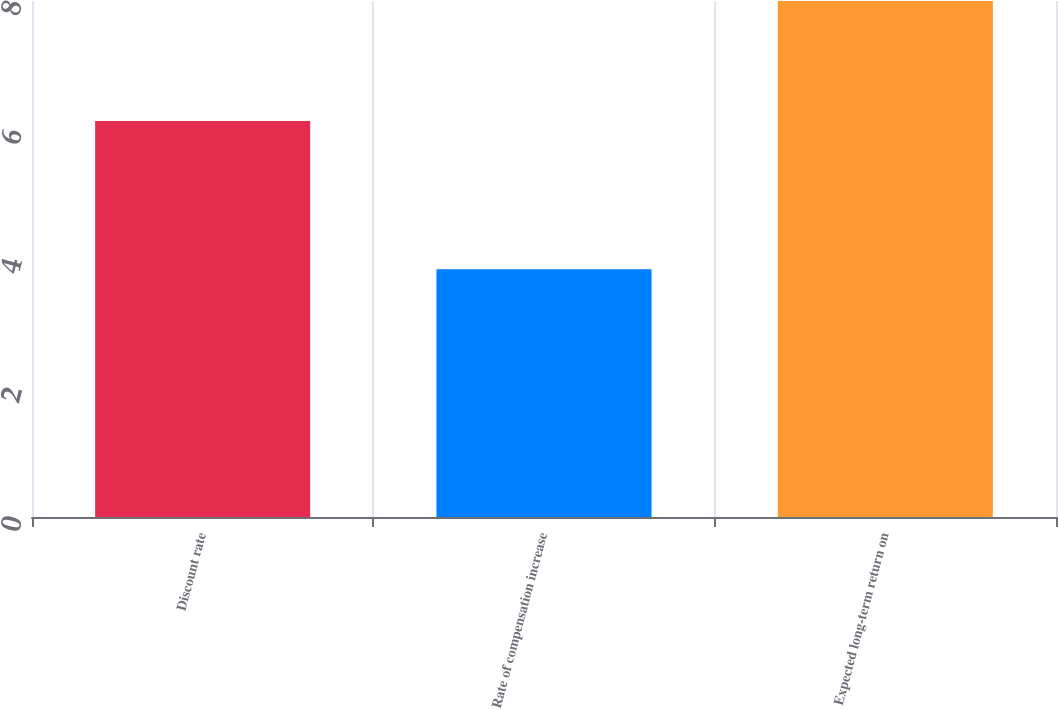<chart> <loc_0><loc_0><loc_500><loc_500><bar_chart><fcel>Discount rate<fcel>Rate of compensation increase<fcel>Expected long-term return on<nl><fcel>6.14<fcel>3.84<fcel>8<nl></chart> 